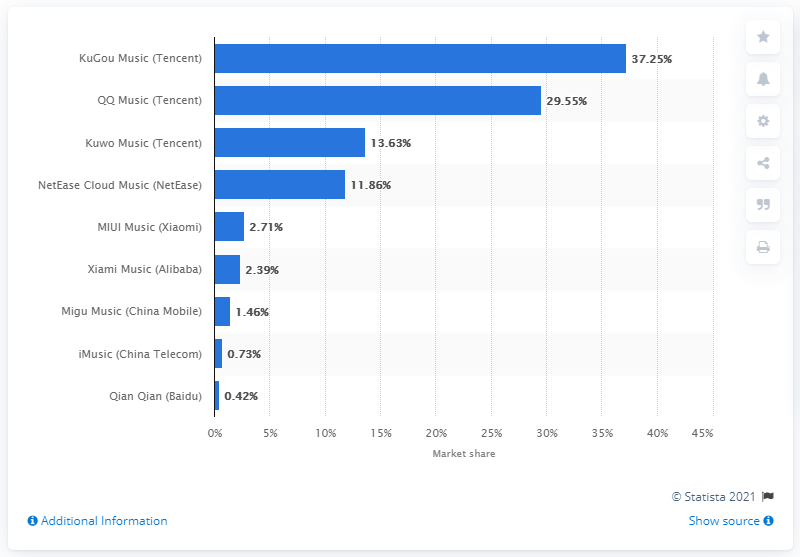Outline some significant characteristics in this image. In 2020, NetEase Cloud Music held a market share of 11.86%. 